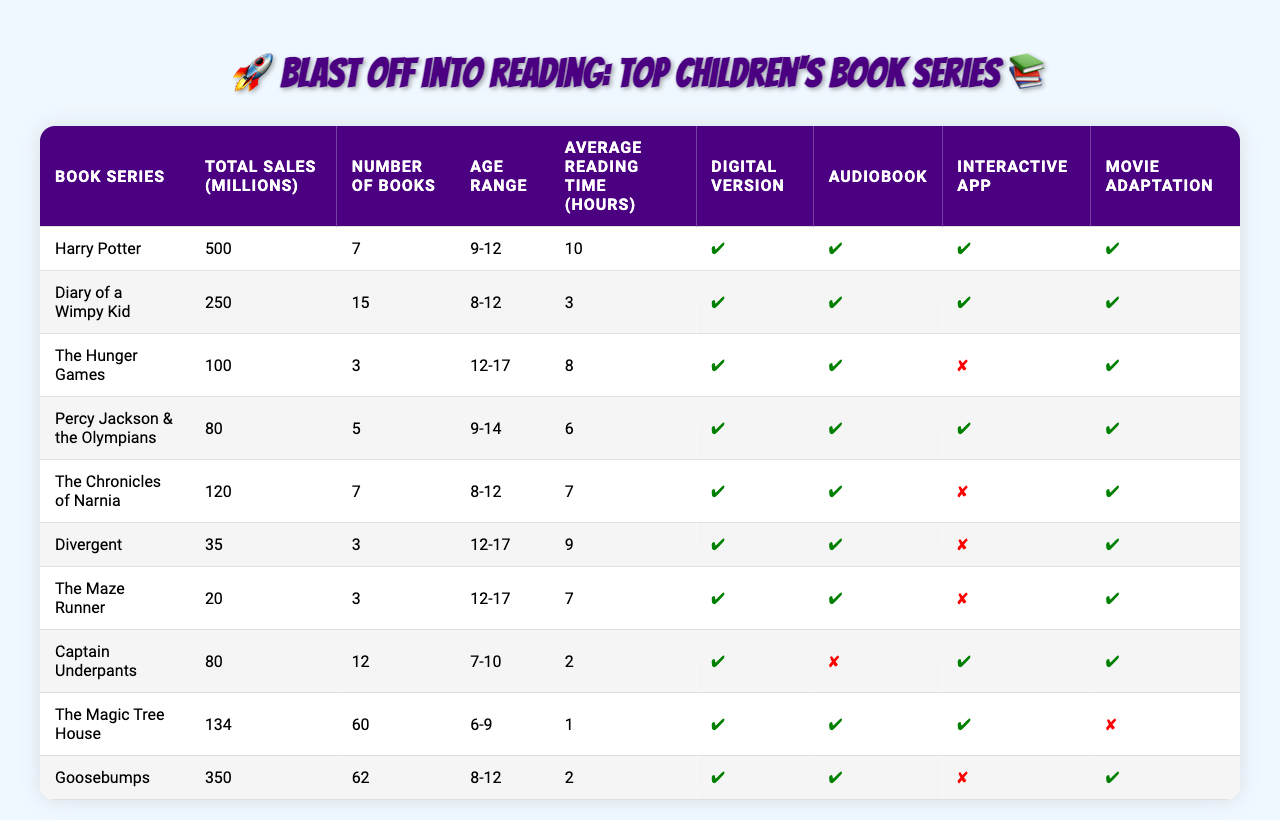What is the total sales figure of the Harry Potter series? The total sales figure for the Harry Potter series is listed in the table under "Total Sales (millions)" corresponding to the series name "Harry Potter," which shows 500 million.
Answer: 500 million How many books are there in the Diary of a Wimpy Kid series? The number of books in the Diary of a Wimpy Kid series can be found in the "Number of Books" column, where the series is listed. It shows that there are 15 books.
Answer: 15 Which book series has the highest total sales? By comparing the "Total Sales (millions)" figures in the table, it's clear that Harry Potter has the highest sales at 500 million, as no other series exceeds this number.
Answer: Harry Potter Are there audiobook versions available for all the series listed? To determine if audiobooks are available for all series, check the "Audiobook Available" column. The table shows that all series except Captain Underpants have audiobooks available.
Answer: No What is the average number of books across all the series? First, we need to sum the "Number of Books" values: 7 + 15 + 3 + 5 + 7 + 3 + 3 + 12 + 60 + 62 =  177. Then, divide by the number of series (10) to find the average: 177 / 10 = 17.7.
Answer: 17.7 Which series has the lowest average reading time? By examining the "Average Reading Time (hours)" column, it is evident that the series with the lowest average reading time is The Magic Tree House, with an average of 1 hour.
Answer: The Magic Tree House How many series are appropriate for an age range of 12-17? Count the occurrences of the age range "12-17" in the "Age Range" column, which appears three times (for The Hunger Games, Divergent, and The Maze Runner).
Answer: 3 Is there an interactive app available for the Percy Jackson & the Olympians series? Check the "Interactive App" column for the Percy Jackson & the Olympians series, which shows "✔," indicating that an interactive app is available.
Answer: Yes What is the total sales of the series that have a movie adaptation? The series with a movie adaptation are Harry Potter, Diary of a Wimpy Kid, The Hunger Games, Percy Jackson & the Olympians, The Chronicles of Narnia, Divergent, The Maze Runner, Captain Underpants, and Goosebumps. Their total sales are: 500 + 250 + 100 + 80 + 120 + 35 + 20 + 80 + 350 = 1,535 million.
Answer: 1,535 million Which children's book series has the most books and what is its total sales? The table shows that Goosebumps has the most books (62), and its total sales amount to 350 million according to the corresponding columns.
Answer: Goosebumps, 350 million What percentage of the book series have an interactive app available? There are 10 series listed, and 6 of them have an interactive app (Harry Potter, Diary of a Wimpy Kid, Percy Jackson & the Olympians, Captain Underpants, The Magic Tree House, and Goosebumps). To find the percentage, calculate (6 / 10) * 100 = 60%.
Answer: 60% 